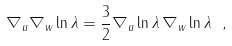Convert formula to latex. <formula><loc_0><loc_0><loc_500><loc_500>\nabla _ { u } \nabla _ { w } \ln \lambda = \frac { 3 } { 2 } \nabla _ { u } \ln \lambda \, \nabla _ { w } \ln \lambda \ ,</formula> 